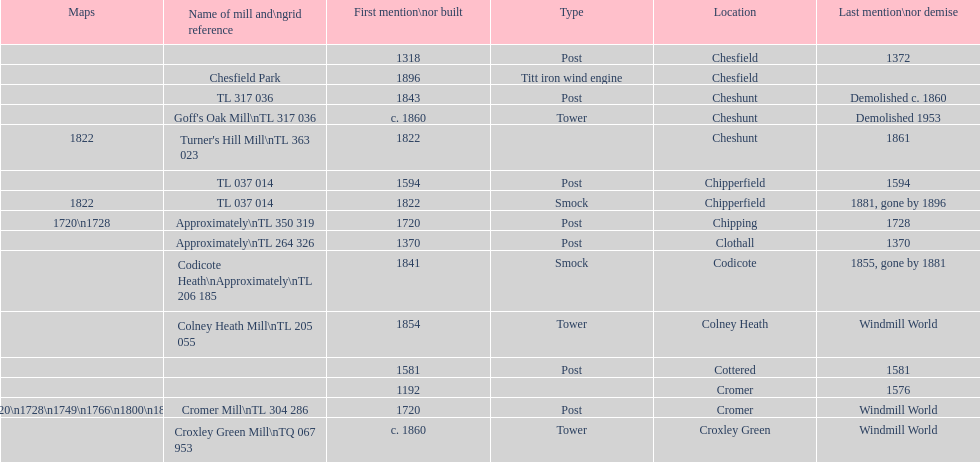What is the total number of mills named cheshunt? 3. 